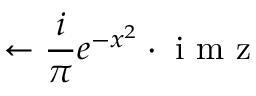Convert formula to latex. <formula><loc_0><loc_0><loc_500><loc_500>\leftarrow \frac { i } { \pi } e ^ { - x ^ { 2 } } \cdot i m z</formula> 